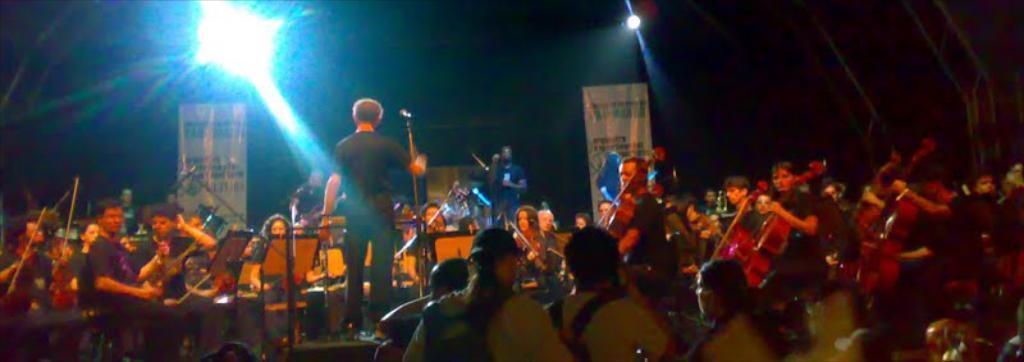Can you describe this image briefly? In this image a person is standing at the center and is holding a microphone, in front of him there is a group of people sitting and playing music instruments, in front of them there are audience and in the background there are posters and lights. 